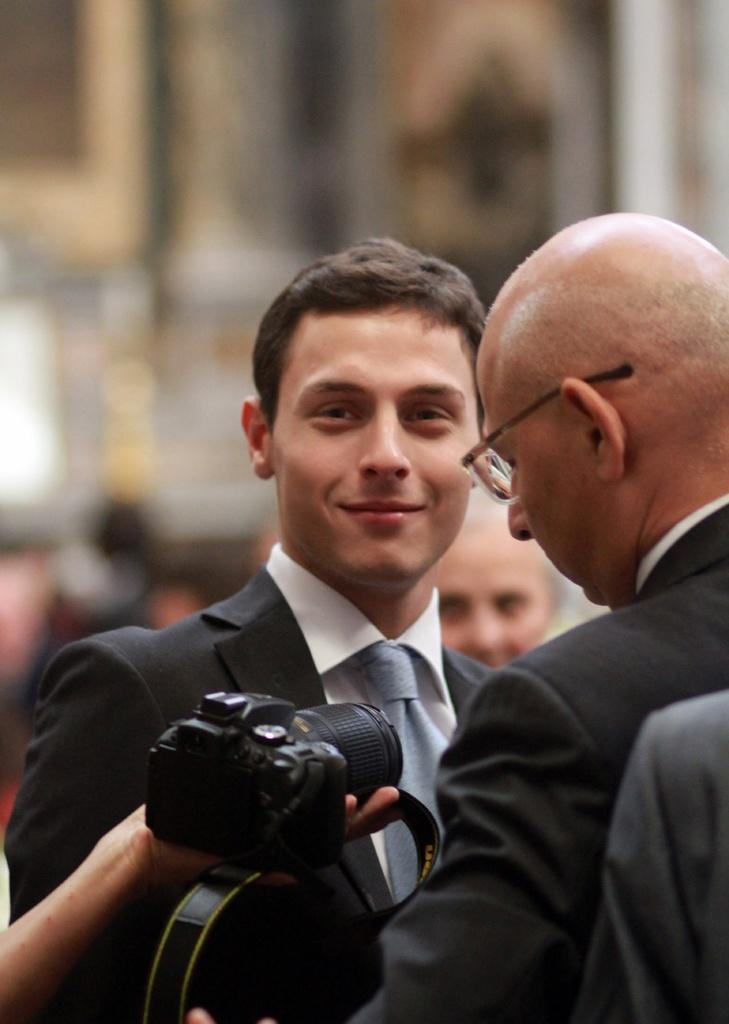How many people are in the image? There are two people in the image. What are the people wearing? Both people are wearing black suits. Can you describe the person holding an object in the image? There is a person holding a camera in the image. How many icicles can be seen hanging from the person's suit in the image? There are no icicles present in the image. What direction are the people facing in the image? The provided facts do not specify the direction the people are facing, so we cannot answer this question definitively. 